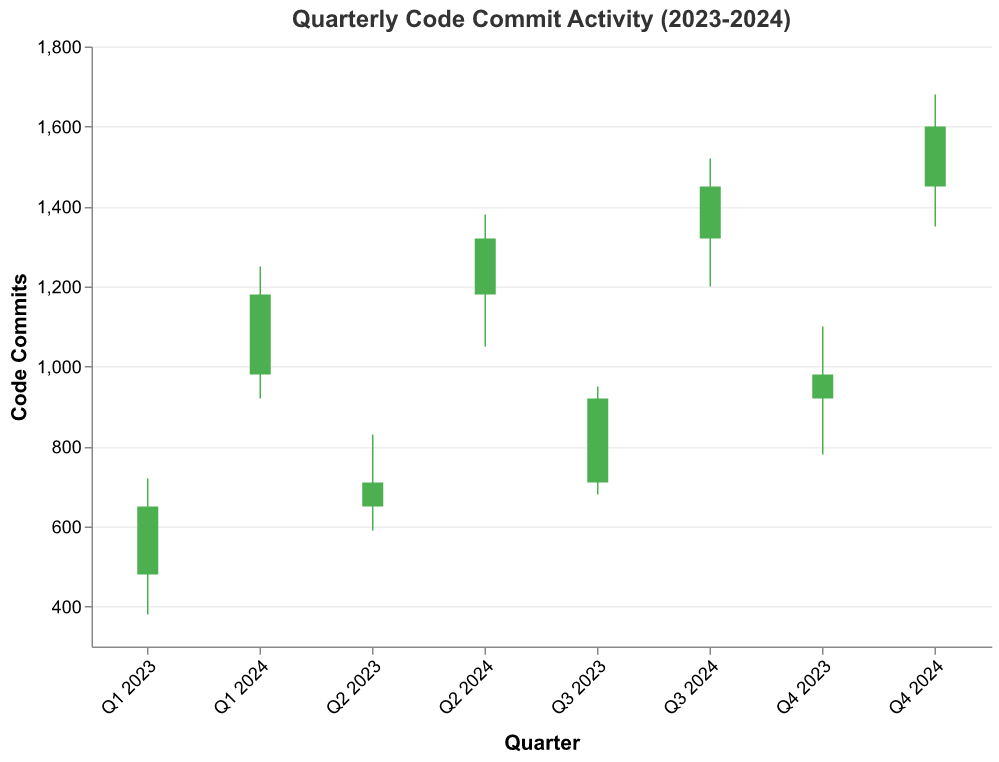How many quarters of data are presented in the figure? The figure starts from Q1 2023 and ends at Q4 2024. Count the quarters, which are 8 in total (Q1, Q2, Q3, Q4 for both 2023 and 2024).
Answer: 8 What is the highest code commit activity and in which quarter did it occur? The highest code commit activity is represented by the highest "High" value in the chart. The highest "High" value is 1680 in Q4 2024.
Answer: Q4 2024 Which quarter demonstrates the lowest "Low" value and what is that value? Identify the "Low" values for each quarter and find the minimum. The minimum "Low" value is 380 in Q1 2023.
Answer: Q1 2023, 380 Was there a significant increase or decrease in the closing value from Q3 2023 to Q4 2023? Compare the "Close" values of Q3 2023 (920) and Q4 2023 (980). Subtract 920 from 980; hence, there is an increase of 60.
Answer: Increase, 60 By how much did the "Open" value change from Q1 2023 to Q4 2024? Subtract the "Open" value of Q1 2023 (480) from Q4 2024 (1450). The change is 1450 - 480 = 970.
Answer: 970 What is the average "Close" value for the year 2023? Sum the "Close" values for all quarters in 2023 (650 + 710 + 920 + 980) and divide by 4. The average is (650 + 710 + 920 + 980) / 4 = 815.
Answer: 815 Which quarter in 2024 had the least range between the "High" and "Low" values? Calculate the range (High - Low) for each quarter in 2024 and find the minimum. Q1 2024: 1250-920 = 330, Q2 2024: 1380-1050 = 330, Q3 2024: 1520-1200 = 320, Q4 2024: 1680-1350 = 330. Q3 2024 has the smallest range of 320.
Answer: Q3 2024 Compare the overall trend of closing values in 2023 with 2024. Which year shows a greater increase? Calculate the net change in "Close" values between Q1 and Q4 for each year. For 2023: 980 - 650 = 330; for 2024: 1600 - 1180 = 420. 2024 shows a greater increase.
Answer: 2024 What general color pattern indicates a rise in code commits for a quarter? Identify the color condition for rising code commits, which is when "Open < Close". This is highlighted in green.
Answer: Green 